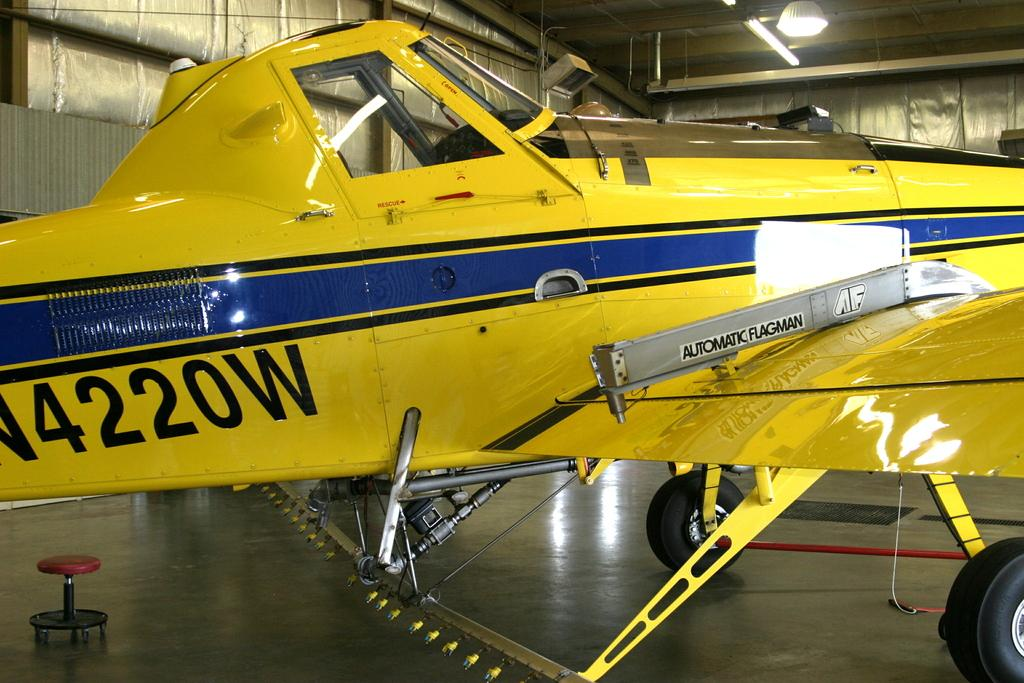<image>
Create a compact narrative representing the image presented. A yellow plane with a blue stripe on the side with the numbers 4220W 